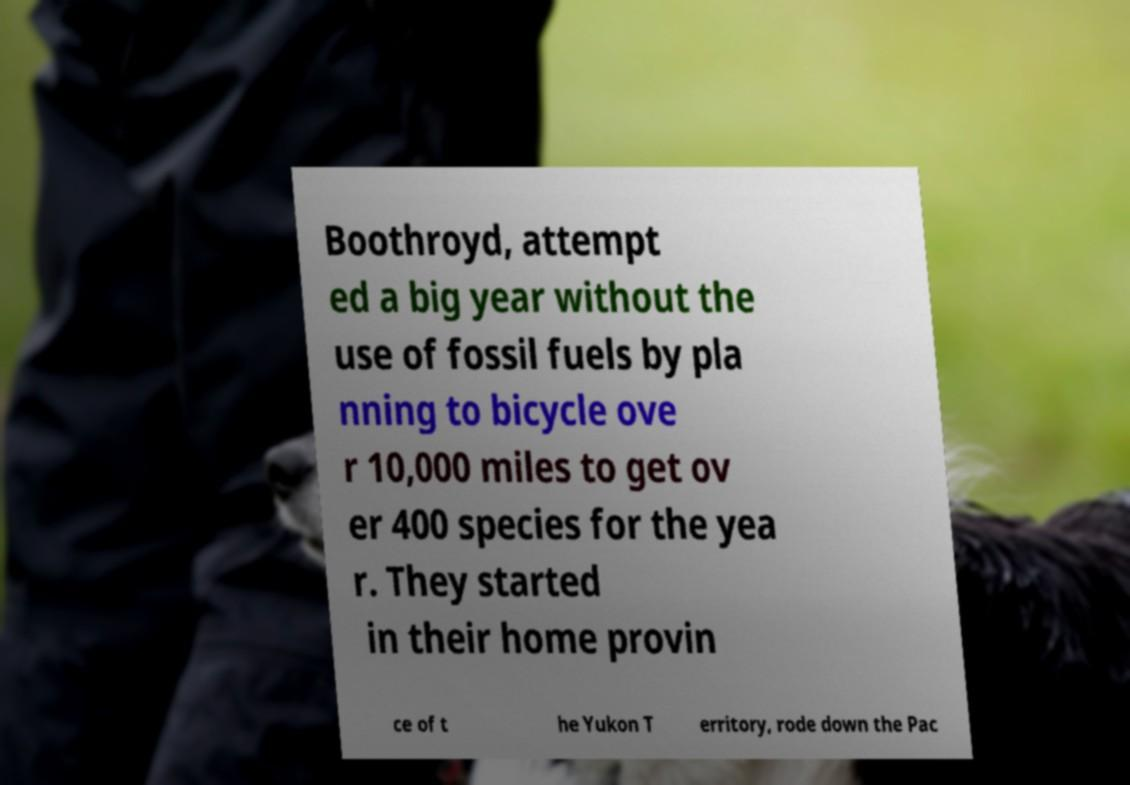I need the written content from this picture converted into text. Can you do that? Boothroyd, attempt ed a big year without the use of fossil fuels by pla nning to bicycle ove r 10,000 miles to get ov er 400 species for the yea r. They started in their home provin ce of t he Yukon T erritory, rode down the Pac 